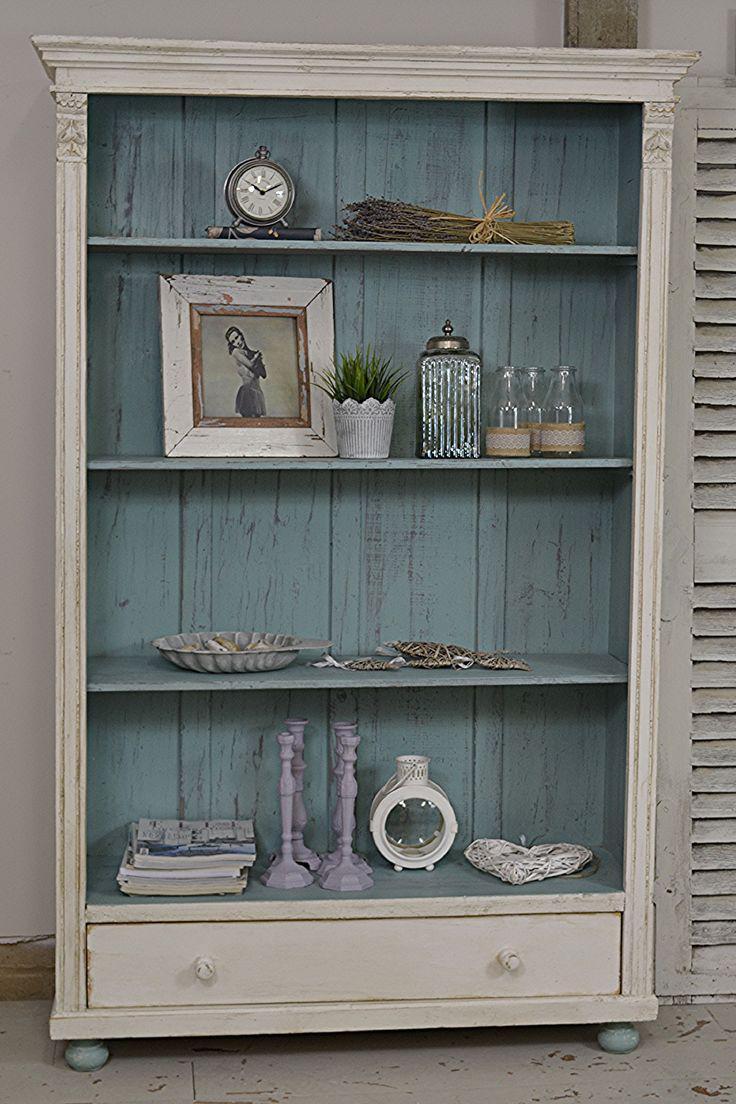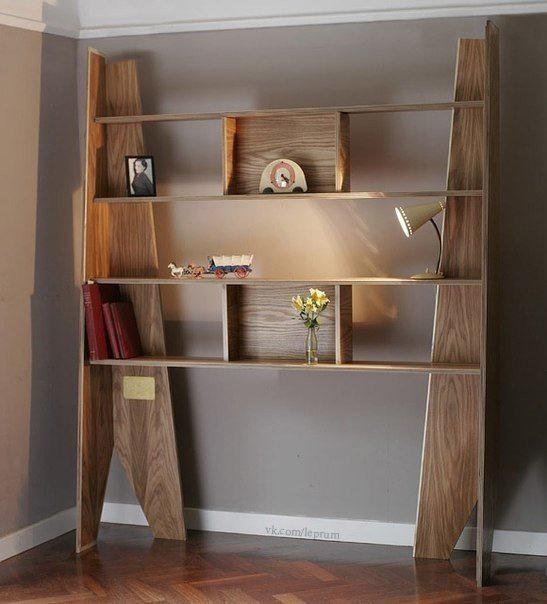The first image is the image on the left, the second image is the image on the right. Assess this claim about the two images: "An image shows a four-shelf cabinet with a blue and white color scheme and plank wood back.". Correct or not? Answer yes or no. Yes. The first image is the image on the left, the second image is the image on the right. Considering the images on both sides, is "One of the images contains a book shelf that is blue and white." valid? Answer yes or no. Yes. 